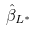<formula> <loc_0><loc_0><loc_500><loc_500>\hat { \beta } _ { L ^ { * } }</formula> 